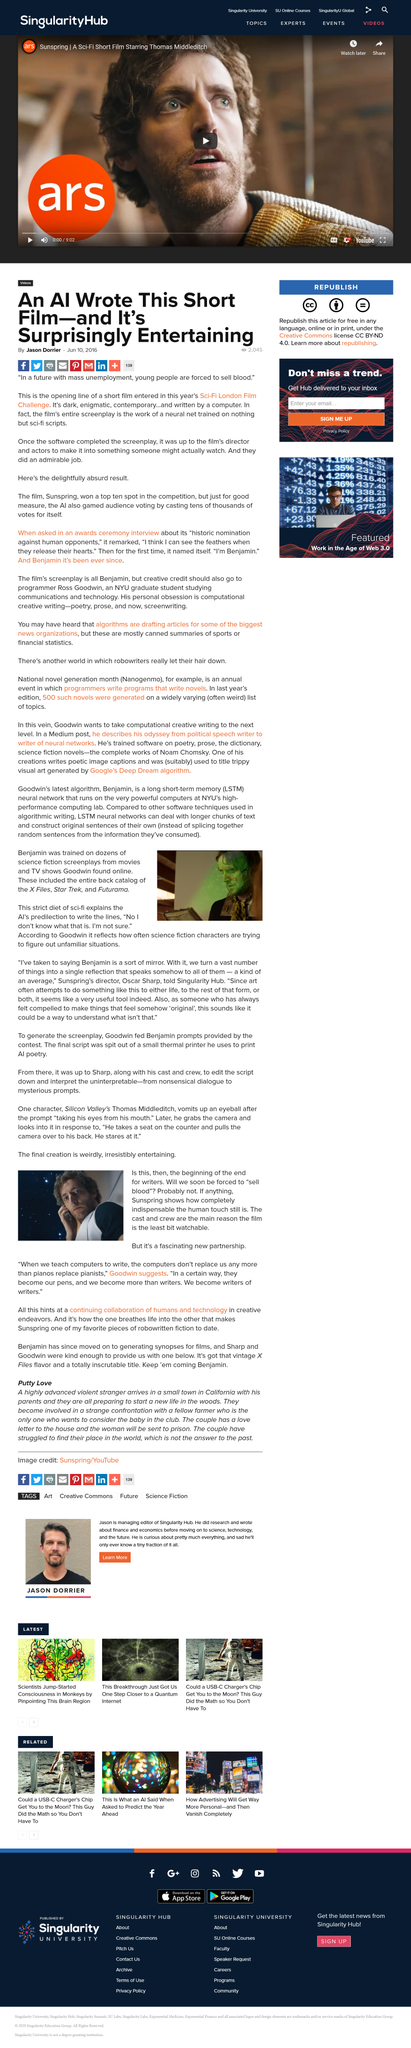Specify some key components in this picture. Goodwin's vision for the future is that computers will become our pens and we will become more than just writers, but writers of writers. We will have the power to create and shape the thoughts and ideas of future generations. The film 'Sunspring' was entered into the Sci-Fi London Film Challenge, a festival dedicated to showcasing the best in science fiction cinema. This film suggests a future where humans and technology continue to work together in a harmonious manner. The short film 'Sunspring' was written by an AI software, making it the first of its kind to be credited with such a feat. What is Benjamin?" is a question that can be answered by stating the name of the person in question. 